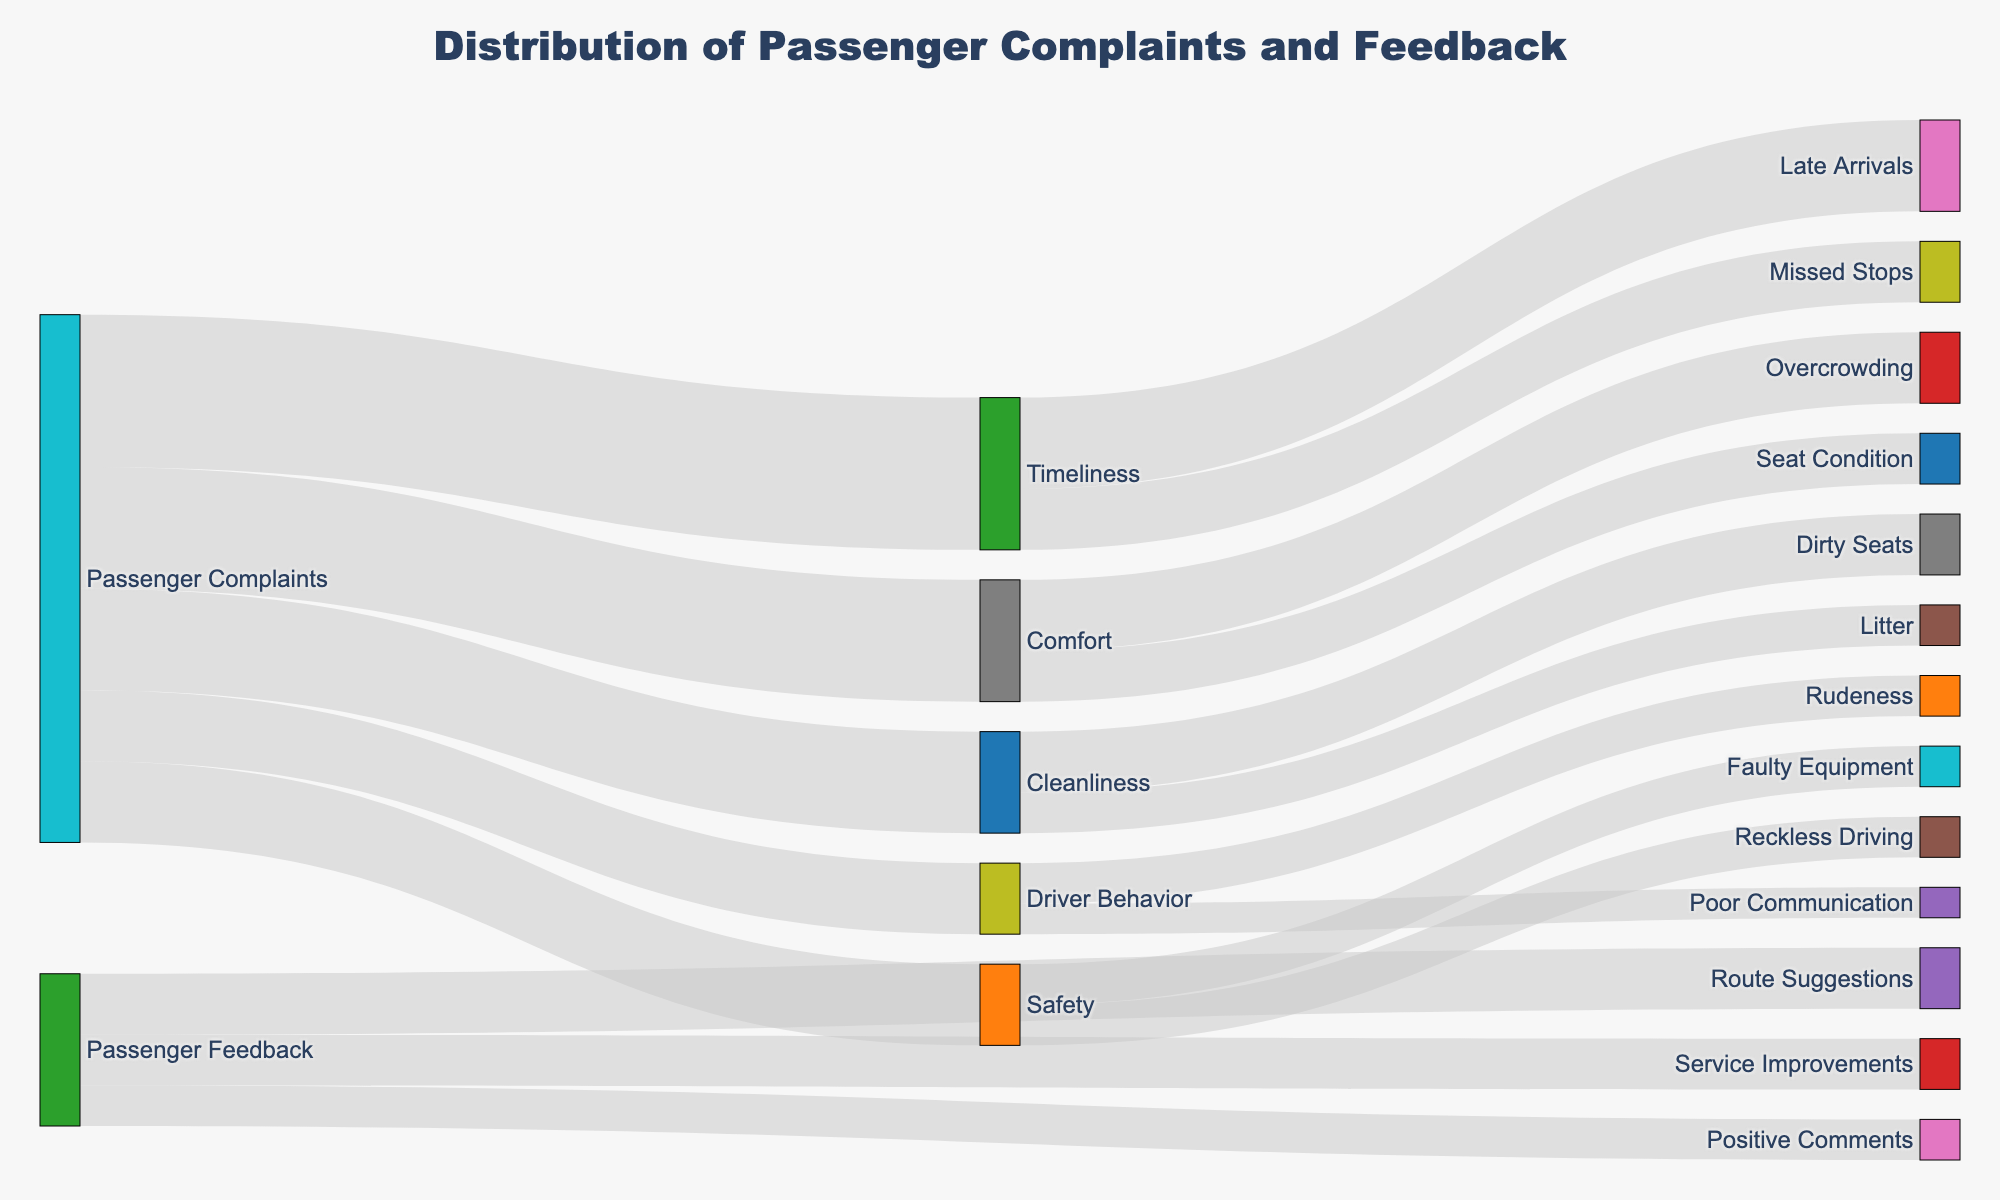What is the title of the figure? The title is prominently displayed at the top of the figure, indicating its main focus or content.
Answer: Distribution of Passenger Complaints and Feedback How many service aspects are connected to Passenger Complaints? Each visual flow from the "Passenger Complaints" node represents a service aspect. Counting these nodes will give the answer. Timeliness, Comfort, Safety, Cleanliness, Driver Behavior.
Answer: 5 Which service aspect receives the highest number of complaints? By following the flows from "Passenger Complaints" and comparing the numeric values, the highest value can be identified. Timeliness has the highest value (150).
Answer: Timeliness What is the combined total of complaints for Comfort and Cleanliness? Add the values of Comfort and Cleanliness connected from Passenger Complaints. Comfort (120) + Cleanliness (100) = 220.
Answer: 220 Which type of complaint is more frequent: Reckless Driving or Overcrowding? Follow the flows from Safety and Comfort to Reckless Driving and Overcrowding and compare their values. Reckless Driving (40) and Overcrowding (70).
Answer: Overcrowding What percentage of all Passenger Complaints is about Safety? Calculate Safety's complaints as a percentage of total complaints. The total complaints are (150+120+80+100+70) = 520. Safety's complaints are 80. (80/520) * 100 ≈ 15.38%.
Answer: 15.38% What kind of feedback has the lowest number of responses? Among the types mentioned under Passenger Feedback, Route Suggestions (60), Service Improvements (50), Positive Comments (40). Positive Comments has the lowest value (40).
Answer: Positive Comments Are complaints about Driver Behavior or Positive Comments higher in number? Compare the two values found in Driver Behavior and Positive Comments flows. Driver Behavior (70) and Positive Comments (40).
Answer: Driver Behavior If complaints about Missed Stops are reduced to zero, how many complaints would Timeliness receive in total? Subtract Missed Stops complaints from Timeliness total complaints initially. Timeliness currently has (90+60) from Late Arrivals and Missed Stops = 150. Without Missed Stops = (150 - 60) = 90.
Answer: 90 